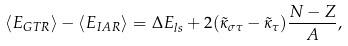<formula> <loc_0><loc_0><loc_500><loc_500>\langle E _ { G T R } \rangle - \langle E _ { I A R } \rangle = \Delta E _ { l s } + 2 ( \tilde { \kappa } _ { \sigma \tau } - \tilde { \kappa } _ { \tau } ) \frac { N - Z } { A } ,</formula> 